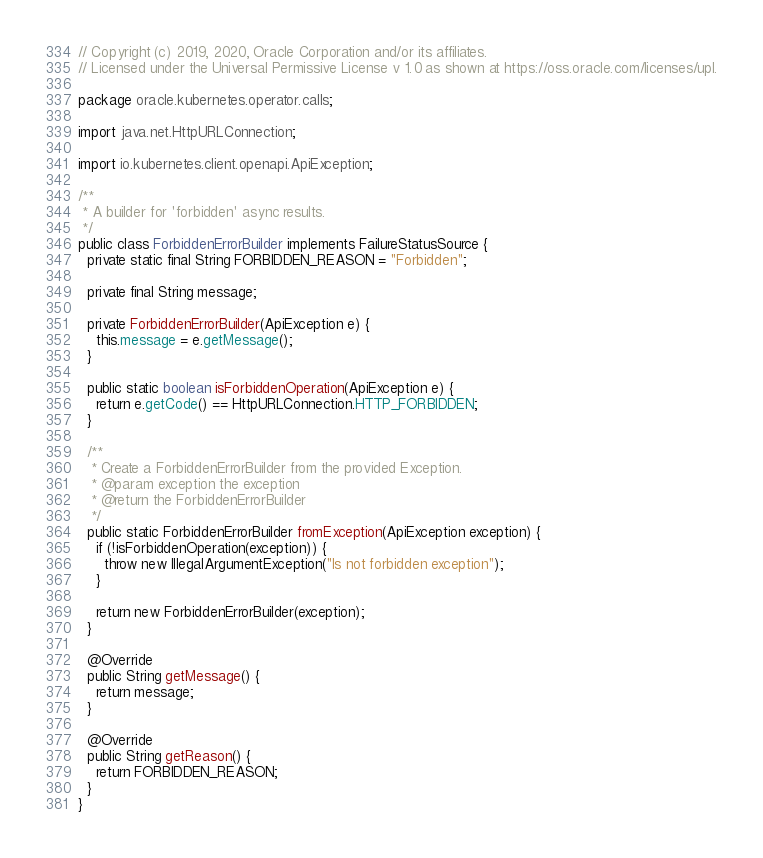Convert code to text. <code><loc_0><loc_0><loc_500><loc_500><_Java_>// Copyright (c) 2019, 2020, Oracle Corporation and/or its affiliates.
// Licensed under the Universal Permissive License v 1.0 as shown at https://oss.oracle.com/licenses/upl.

package oracle.kubernetes.operator.calls;

import java.net.HttpURLConnection;

import io.kubernetes.client.openapi.ApiException;

/**
 * A builder for 'forbidden' async results.
 */
public class ForbiddenErrorBuilder implements FailureStatusSource {
  private static final String FORBIDDEN_REASON = "Forbidden";

  private final String message;

  private ForbiddenErrorBuilder(ApiException e) {
    this.message = e.getMessage();
  }

  public static boolean isForbiddenOperation(ApiException e) {
    return e.getCode() == HttpURLConnection.HTTP_FORBIDDEN;
  }

  /**
   * Create a ForbiddenErrorBuilder from the provided Exception.
   * @param exception the exception
   * @return the ForbiddenErrorBuilder
   */
  public static ForbiddenErrorBuilder fromException(ApiException exception) {
    if (!isForbiddenOperation(exception)) {
      throw new IllegalArgumentException("Is not forbidden exception");
    }

    return new ForbiddenErrorBuilder(exception);
  }

  @Override
  public String getMessage() {
    return message;
  }

  @Override
  public String getReason() {
    return FORBIDDEN_REASON;
  }
}
</code> 